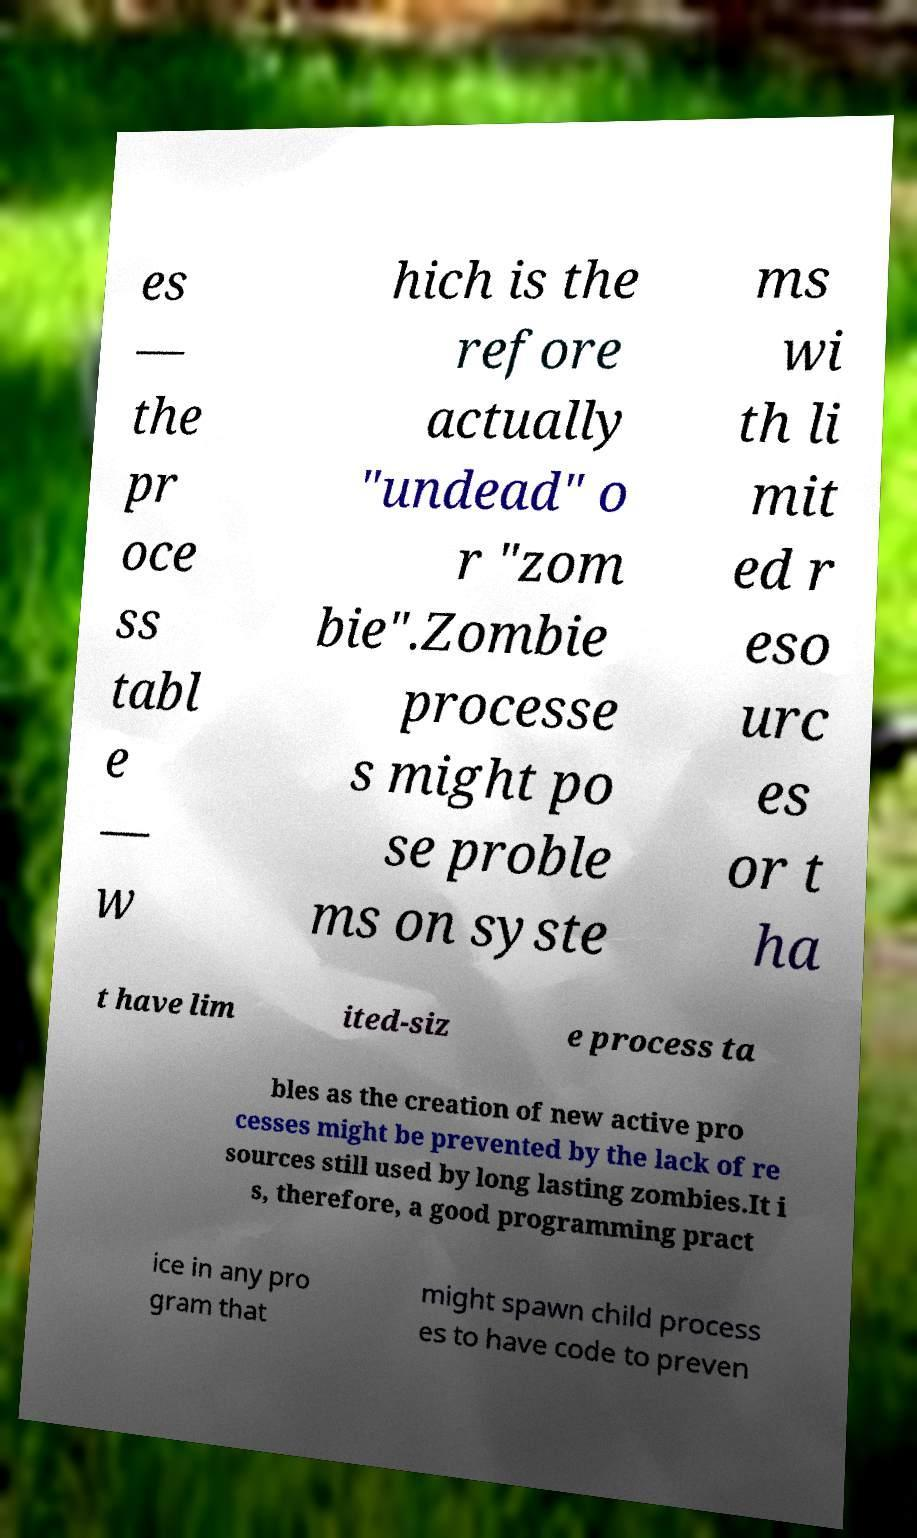What messages or text are displayed in this image? I need them in a readable, typed format. es — the pr oce ss tabl e — w hich is the refore actually "undead" o r "zom bie".Zombie processe s might po se proble ms on syste ms wi th li mit ed r eso urc es or t ha t have lim ited-siz e process ta bles as the creation of new active pro cesses might be prevented by the lack of re sources still used by long lasting zombies.It i s, therefore, a good programming pract ice in any pro gram that might spawn child process es to have code to preven 